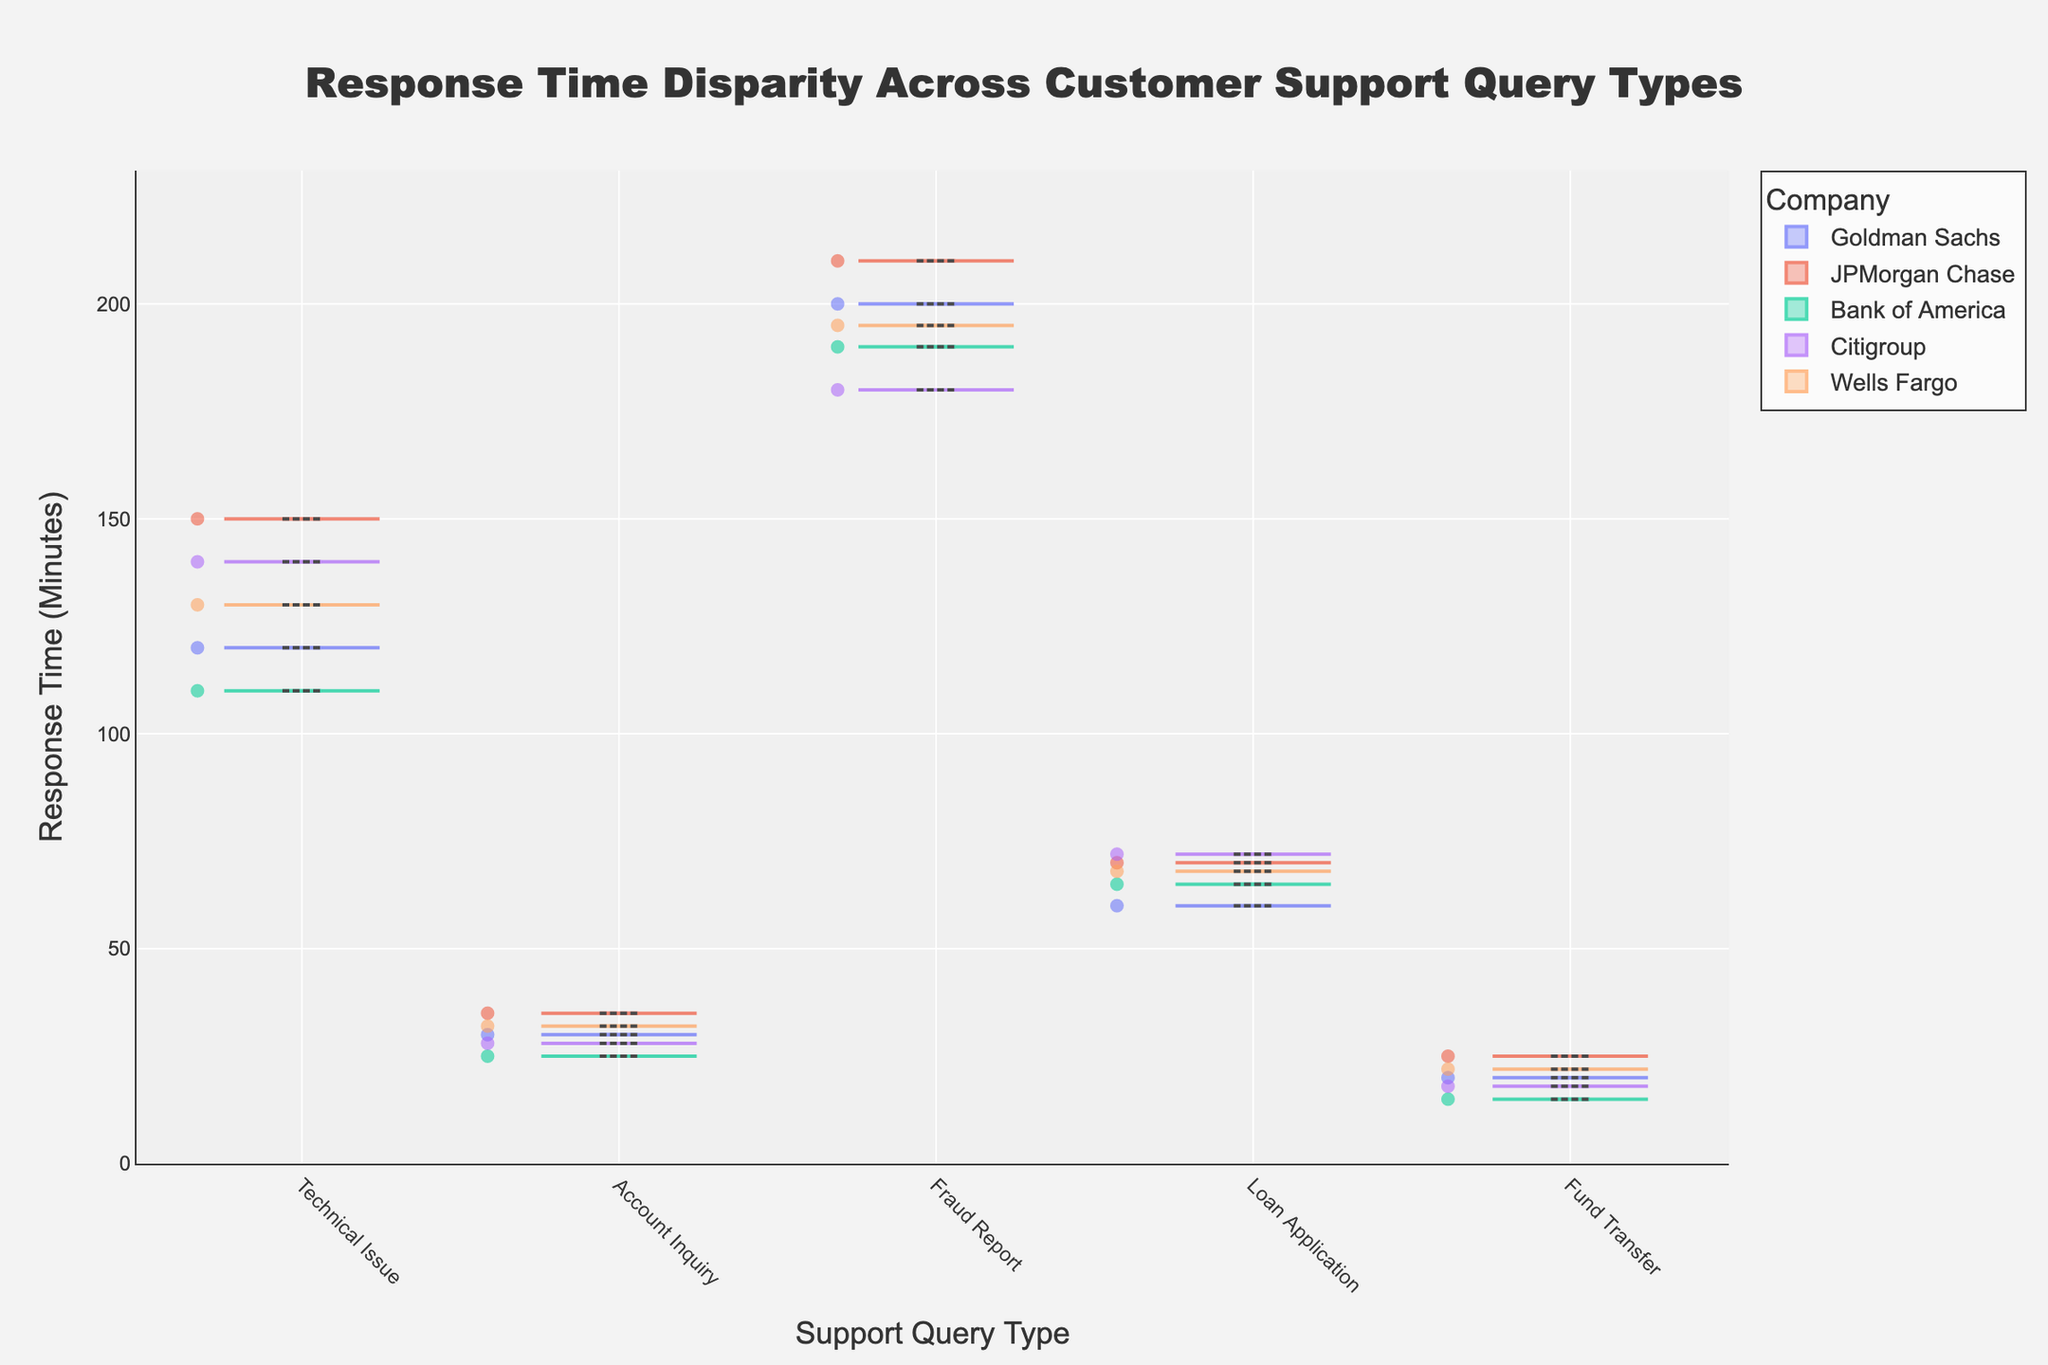What are the different support query types shown in the chart? The support query types can be identified along the x-axis of the violin chart. They are labeled as "Technical Issue", "Account Inquiry", "Fraud Report", "Loan Application", and "Fund Transfer".
Answer: Technical Issue, Account Inquiry, Fraud Report, Loan Application, Fund Transfer What is the title of the chart? The title of the chart is displayed at the top of the figure in bold text.
Answer: Response Time Disparity Across Customer Support Query Types Which company has the lowest response time for "Technical Issue" queries? By observing the "Technical Issue" section of the chart, the violin plot with the lowest minimum point belongs to "Bank of America".
Answer: Bank of America What is the range of response times for "Account Inquiry" queries? Looking at the "Account Inquiry" section of the violin chart, the lowest point is at 25 minutes and the highest point is at 35 minutes.
Answer: 25 to 35 minutes What type of support query has the highest median response time? To find the highest median response time, look at the bold line at the center of each violin plot. "Fraud Report" has the highest median response time across all types.
Answer: Fraud Report Which support query type shows the most variation in response times? The most variation can be gauged by the width and spread of the violin plots. "Fraud Report" shows the widest spread, indicating the highest variation.
Answer: Fraud Report How does the median response time for "Loan Application" queries compare between all companies? The median response time for "Loan Application" is shown as a bold line in each company’s violin plot. All companies have similar medians around 65-70 minutes.
Answer: Similar around 65-70 minutes Are the response times for "Fund Transfer" queries consistently low across all companies? Observing the "Fund Transfer" section, the response times are consistently low, ranging from 15 to 25 minutes, for all companies.
Answer: Yes What is the average response time for "Technical Issue" queries from Goldman Sachs and JPMorgan Chase? First, identify the response times for "Technical Issue" queries from Goldman Sachs (120, 140) and JPMorgan Chase (150). Calculate the average: (120 + 140 + 150) / 3 = 410 / 3 ≈ 137 minutes.
Answer: 137 minutes Which type of support query does Citigroup handle the fastest? By comparing the lowest points in each violin plot for Citigroup, "Fund Transfer" has the fastest response time at 18 minutes.
Answer: Fund Transfer 